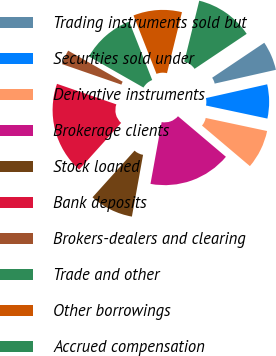Convert chart. <chart><loc_0><loc_0><loc_500><loc_500><pie_chart><fcel>Trading instruments sold but<fcel>Securities sold under<fcel>Derivative instruments<fcel>Brokerage clients<fcel>Stock loaned<fcel>Bank deposits<fcel>Brokers-dealers and clearing<fcel>Trade and other<fcel>Other borrowings<fcel>Accrued compensation<nl><fcel>5.88%<fcel>6.86%<fcel>7.84%<fcel>16.67%<fcel>8.82%<fcel>18.63%<fcel>2.94%<fcel>10.78%<fcel>9.8%<fcel>11.76%<nl></chart> 